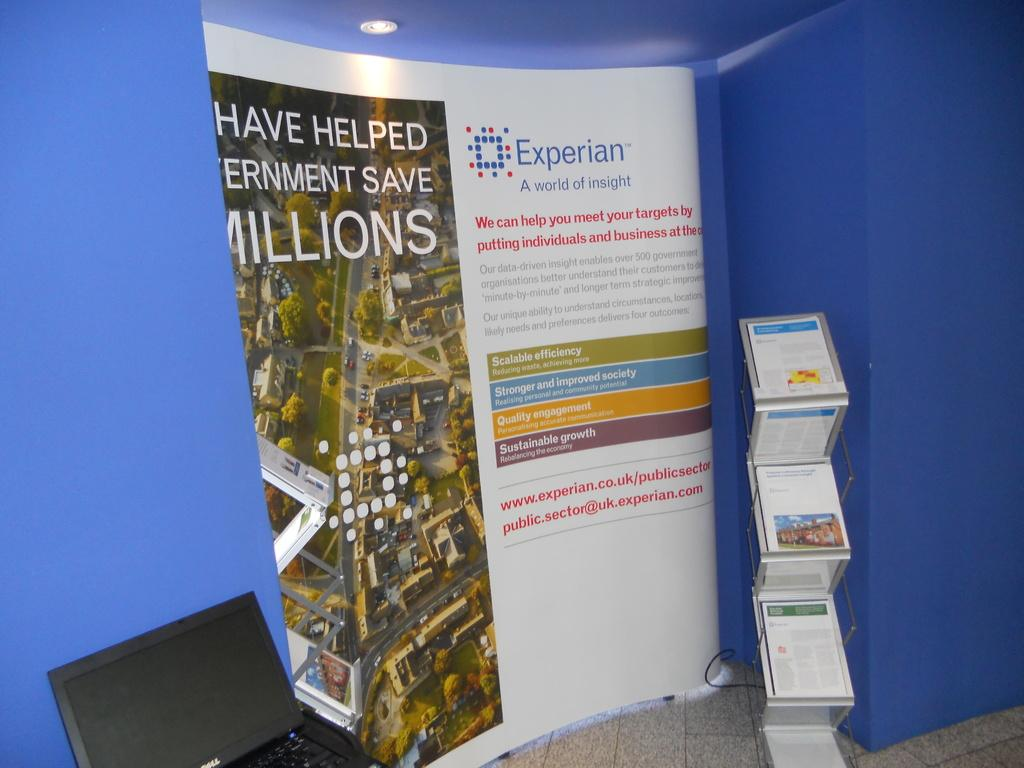<image>
Give a short and clear explanation of the subsequent image. An Experian poster is in the corner by blue walls. 